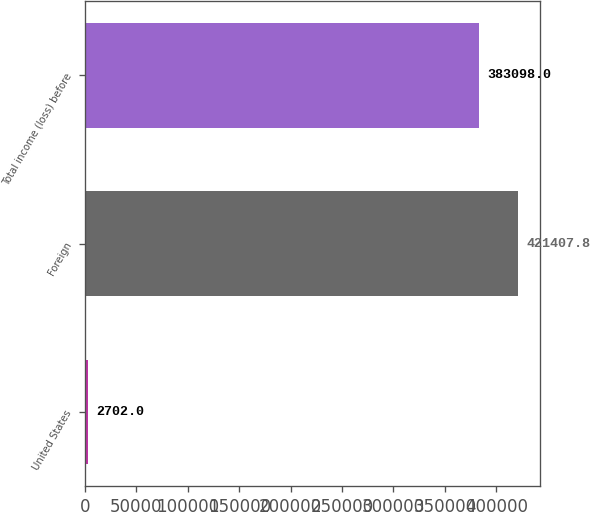<chart> <loc_0><loc_0><loc_500><loc_500><bar_chart><fcel>United States<fcel>Foreign<fcel>Total income (loss) before<nl><fcel>2702<fcel>421408<fcel>383098<nl></chart> 